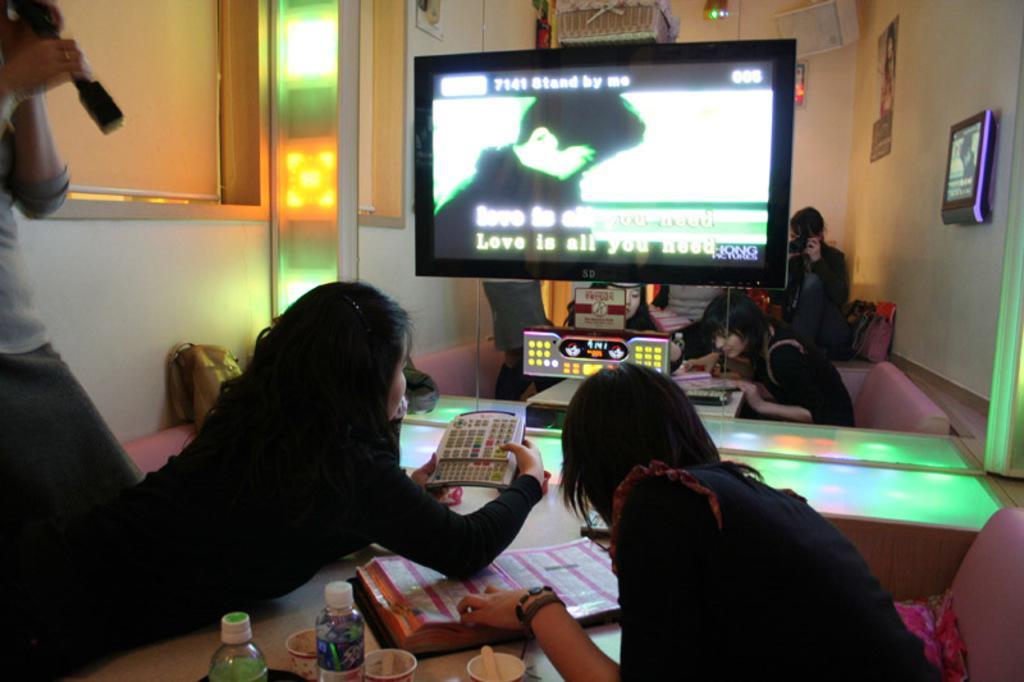How would you summarize this image in a sentence or two? In this picture we can see some persons sitting on the chairs. This is table. On the table there are bottles, cups, and a book. Here we can see a screen and this is wall. And there are frames and these are the lights. 